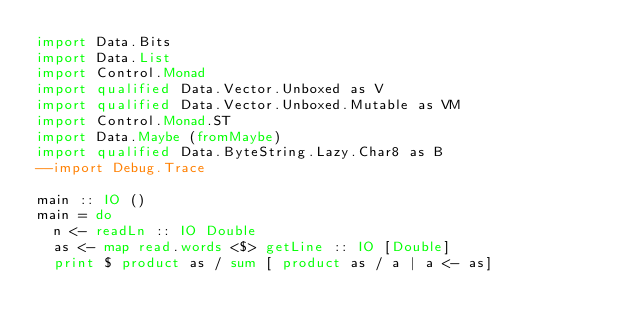Convert code to text. <code><loc_0><loc_0><loc_500><loc_500><_Haskell_>import Data.Bits
import Data.List
import Control.Monad
import qualified Data.Vector.Unboxed as V
import qualified Data.Vector.Unboxed.Mutable as VM
import Control.Monad.ST
import Data.Maybe (fromMaybe)
import qualified Data.ByteString.Lazy.Char8 as B
--import Debug.Trace

main :: IO ()
main = do
  n <- readLn :: IO Double
  as <- map read.words <$> getLine :: IO [Double]
  print $ product as / sum [ product as / a | a <- as]
</code> 